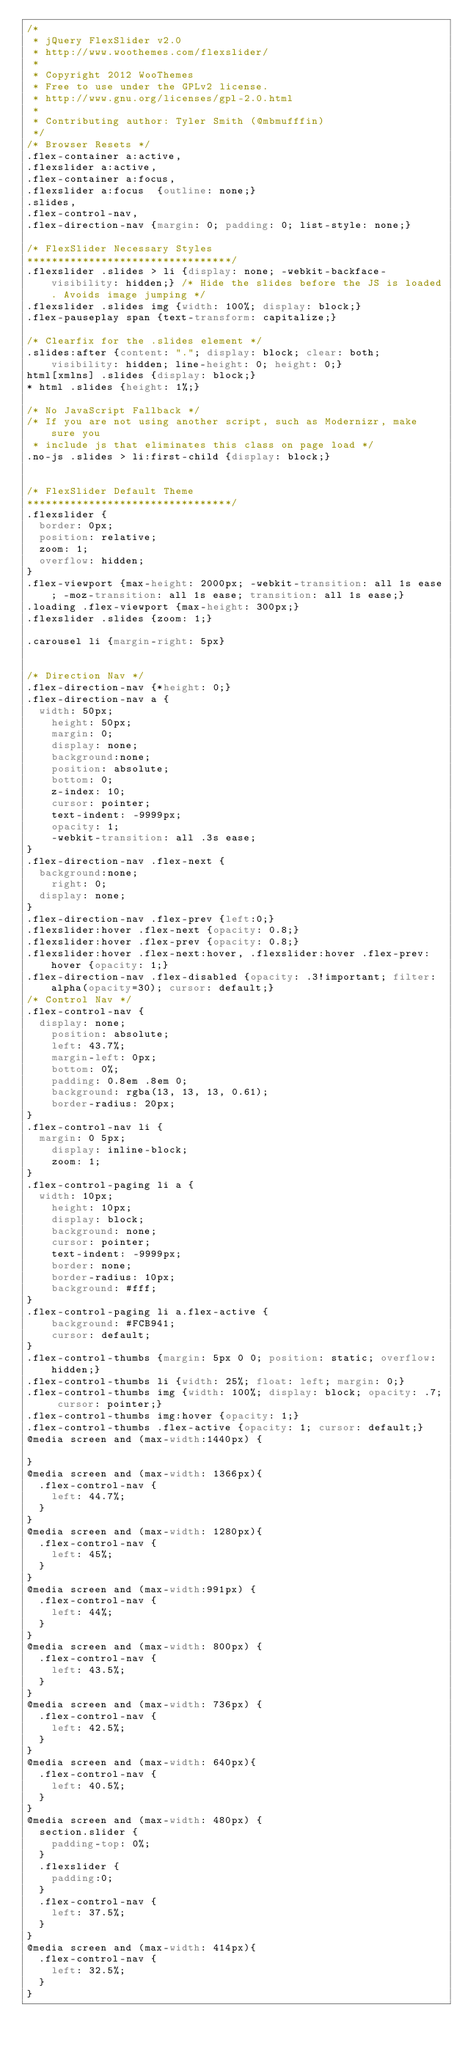<code> <loc_0><loc_0><loc_500><loc_500><_CSS_>/*
 * jQuery FlexSlider v2.0
 * http://www.woothemes.com/flexslider/
 *
 * Copyright 2012 WooThemes
 * Free to use under the GPLv2 license.
 * http://www.gnu.org/licenses/gpl-2.0.html
 *
 * Contributing author: Tyler Smith (@mbmufffin)
 */
/* Browser Resets */
.flex-container a:active,
.flexslider a:active,
.flex-container a:focus,
.flexslider a:focus  {outline: none;}
.slides,
.flex-control-nav,
.flex-direction-nav {margin: 0; padding: 0; list-style: none;} 

/* FlexSlider Necessary Styles
*********************************/ 
.flexslider .slides > li {display: none; -webkit-backface-visibility: hidden;} /* Hide the slides before the JS is loaded. Avoids image jumping */
.flexslider .slides img {width: 100%; display: block;}
.flex-pauseplay span {text-transform: capitalize;}

/* Clearfix for the .slides element */
.slides:after {content: "."; display: block; clear: both; visibility: hidden; line-height: 0; height: 0;} 
html[xmlns] .slides {display: block;} 
* html .slides {height: 1%;}

/* No JavaScript Fallback */
/* If you are not using another script, such as Modernizr, make sure you
 * include js that eliminates this class on page load */
.no-js .slides > li:first-child {display: block;}


/* FlexSlider Default Theme
*********************************/
.flexslider {
	border: 0px;
	position: relative;
	zoom: 1;
	overflow: hidden;
}
.flex-viewport {max-height: 2000px; -webkit-transition: all 1s ease; -moz-transition: all 1s ease; transition: all 1s ease;}
.loading .flex-viewport {max-height: 300px;}
.flexslider .slides {zoom: 1;}

.carousel li {margin-right: 5px}


/* Direction Nav */
.flex-direction-nav {*height: 0;}
.flex-direction-nav a {
	width: 50px;
    height: 50px;
    margin: 0;
    display: none;
    background:none;
    position: absolute;
    bottom: 0;
    z-index: 10;
    cursor: pointer;
    text-indent: -9999px;
    opacity: 1;
    -webkit-transition: all .3s ease;
}
.flex-direction-nav .flex-next {
	background:none;
    right: 0;
	display: none;
}
.flex-direction-nav .flex-prev {left:0;}
.flexslider:hover .flex-next {opacity: 0.8;}
.flexslider:hover .flex-prev {opacity: 0.8;}
.flexslider:hover .flex-next:hover, .flexslider:hover .flex-prev:hover {opacity: 1;}
.flex-direction-nav .flex-disabled {opacity: .3!important; filter:alpha(opacity=30); cursor: default;}
/* Control Nav */
.flex-control-nav {
	display: none;
    position: absolute;
    left: 43.7%;
    margin-left: 0px;
    bottom: 0%;
    padding: 0.8em .8em 0;
    background: rgba(13, 13, 13, 0.61);
    border-radius: 20px;
}
.flex-control-nav li {
	margin: 0 5px;
    display: inline-block;
    zoom: 1;
}
.flex-control-paging li a {
	width: 10px;
    height: 10px;
    display: block;
    background: none;
    cursor: pointer;
    text-indent: -9999px;
    border: none;
    border-radius: 10px;
    background: #fff;
}
.flex-control-paging li a.flex-active { 
    background: #FCB941;
    cursor: default;
}
.flex-control-thumbs {margin: 5px 0 0; position: static; overflow: hidden;}
.flex-control-thumbs li {width: 25%; float: left; margin: 0;}
.flex-control-thumbs img {width: 100%; display: block; opacity: .7; cursor: pointer;}
.flex-control-thumbs img:hover {opacity: 1;}
.flex-control-thumbs .flex-active {opacity: 1; cursor: default;}
@media screen and (max-width:1440px) {
	
}
@media screen and (max-width: 1366px){
	.flex-control-nav {
		left: 44.7%;
	}
}
@media screen and (max-width: 1280px){
	.flex-control-nav {
		left: 45%;
	}
}
@media screen and (max-width:991px) {
	.flex-control-nav {
		left: 44%;
	}
}
@media screen and (max-width: 800px) {
	.flex-control-nav {
		left: 43.5%;
	}
}
@media screen and (max-width: 736px) {
	.flex-control-nav {
		left: 42.5%;
	}
}
@media screen and (max-width: 640px){
	.flex-control-nav {
		left: 40.5%;
	}
}
@media screen and (max-width: 480px) {
	section.slider {
		padding-top: 0%;
	}
	.flexslider {
		padding:0;
	}
	.flex-control-nav {
		left: 37.5%;
	}
}
@media screen and (max-width: 414px){
	.flex-control-nav {
		left: 32.5%;
	}
}</code> 